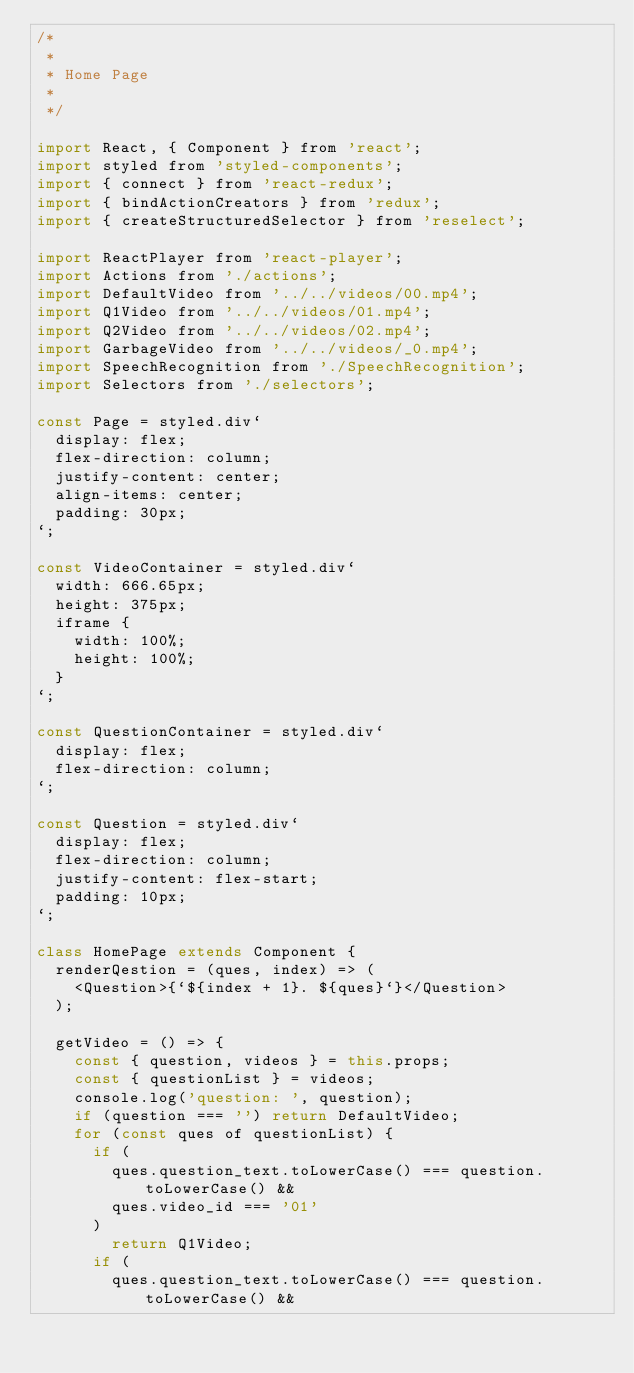<code> <loc_0><loc_0><loc_500><loc_500><_JavaScript_>/*
 *
 * Home Page
 *
 */

import React, { Component } from 'react';
import styled from 'styled-components';
import { connect } from 'react-redux';
import { bindActionCreators } from 'redux';
import { createStructuredSelector } from 'reselect';

import ReactPlayer from 'react-player';
import Actions from './actions';
import DefaultVideo from '../../videos/00.mp4';
import Q1Video from '../../videos/01.mp4';
import Q2Video from '../../videos/02.mp4';
import GarbageVideo from '../../videos/_0.mp4';
import SpeechRecognition from './SpeechRecognition';
import Selectors from './selectors';

const Page = styled.div`
  display: flex;
  flex-direction: column;
  justify-content: center;
  align-items: center;
  padding: 30px;
`;

const VideoContainer = styled.div`
  width: 666.65px;
  height: 375px;
  iframe {
    width: 100%;
    height: 100%;
  }
`;

const QuestionContainer = styled.div`
  display: flex;
  flex-direction: column;
`;

const Question = styled.div`
  display: flex;
  flex-direction: column;
  justify-content: flex-start;
  padding: 10px;
`;

class HomePage extends Component {
  renderQestion = (ques, index) => (
    <Question>{`${index + 1}. ${ques}`}</Question>
  );

  getVideo = () => {
    const { question, videos } = this.props;
    const { questionList } = videos;
    console.log('question: ', question);
    if (question === '') return DefaultVideo;
    for (const ques of questionList) {
      if (
        ques.question_text.toLowerCase() === question.toLowerCase() &&
        ques.video_id === '01'
      )
        return Q1Video;
      if (
        ques.question_text.toLowerCase() === question.toLowerCase() &&</code> 